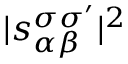Convert formula to latex. <formula><loc_0><loc_0><loc_500><loc_500>| s _ { \alpha \beta } ^ { \sigma \sigma ^ { \prime } } | ^ { 2 }</formula> 